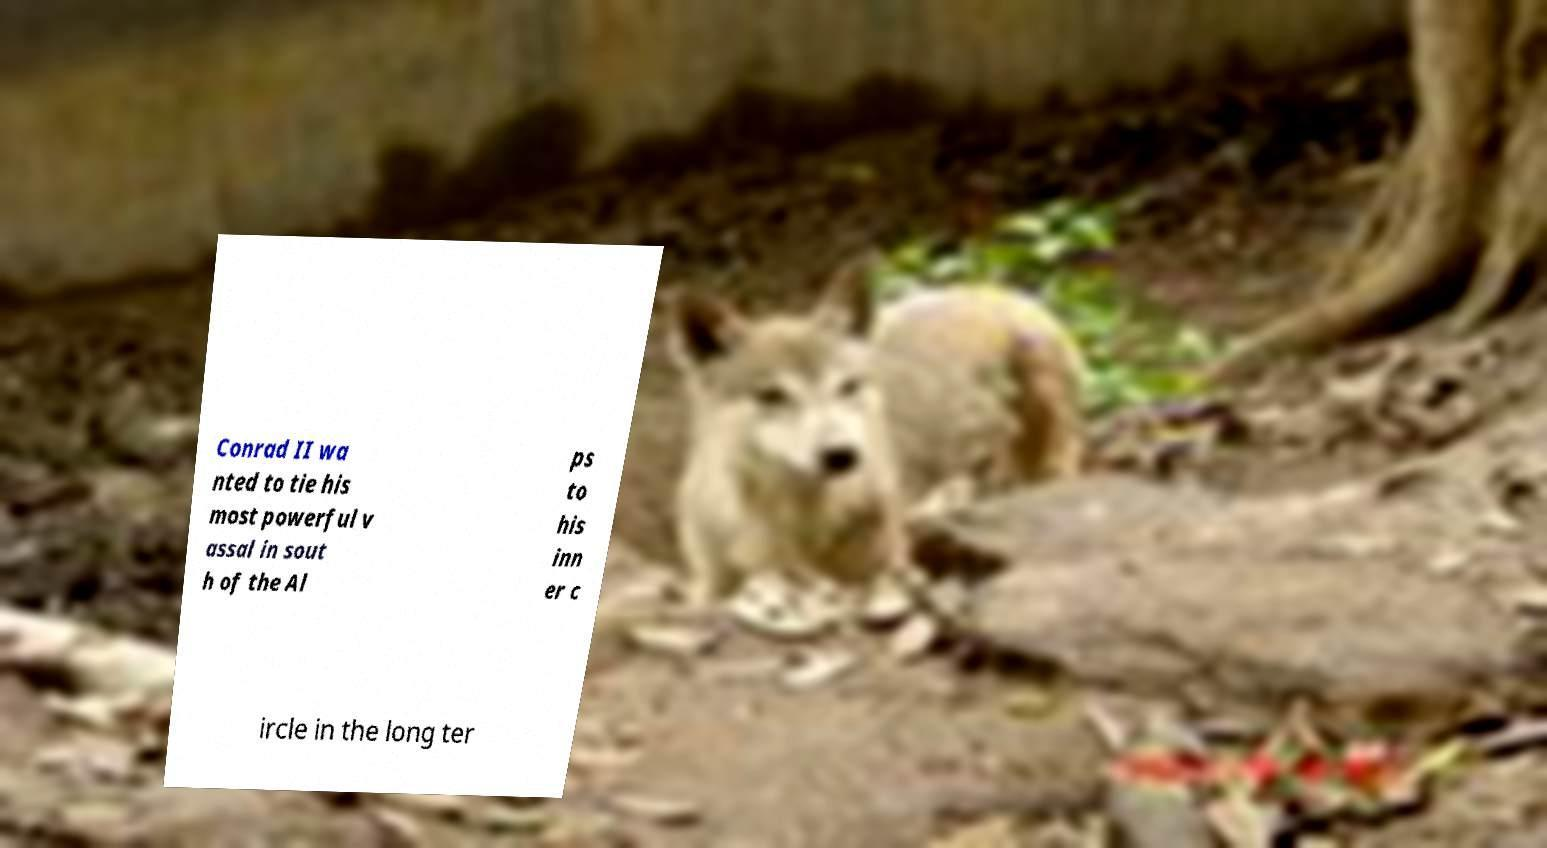Please read and relay the text visible in this image. What does it say? Conrad II wa nted to tie his most powerful v assal in sout h of the Al ps to his inn er c ircle in the long ter 